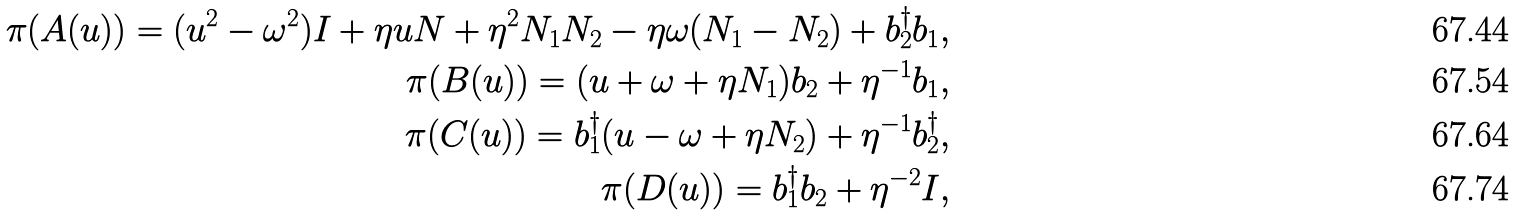<formula> <loc_0><loc_0><loc_500><loc_500>\pi ( { A } ( u ) ) = ( u ^ { 2 } - \omega ^ { 2 } ) I + \eta u N + \eta ^ { 2 } N _ { 1 } N _ { 2 } - \eta \omega ( N _ { 1 } - N _ { 2 } ) + b ^ { \dagger } _ { 2 } b _ { 1 } , \\ \pi ( { B } ( u ) ) = ( u + \omega + \eta N _ { 1 } ) b _ { 2 } + \eta ^ { - 1 } b _ { 1 } , \\ \pi ( { C } ( u ) ) = b ^ { \dagger } _ { 1 } ( u - \omega + \eta N _ { 2 } ) + \eta ^ { - 1 } b ^ { \dagger } _ { 2 } , \\ \pi ( { D } ( u ) ) = b _ { 1 } ^ { \dagger } b _ { 2 } + \eta ^ { - 2 } I ,</formula> 